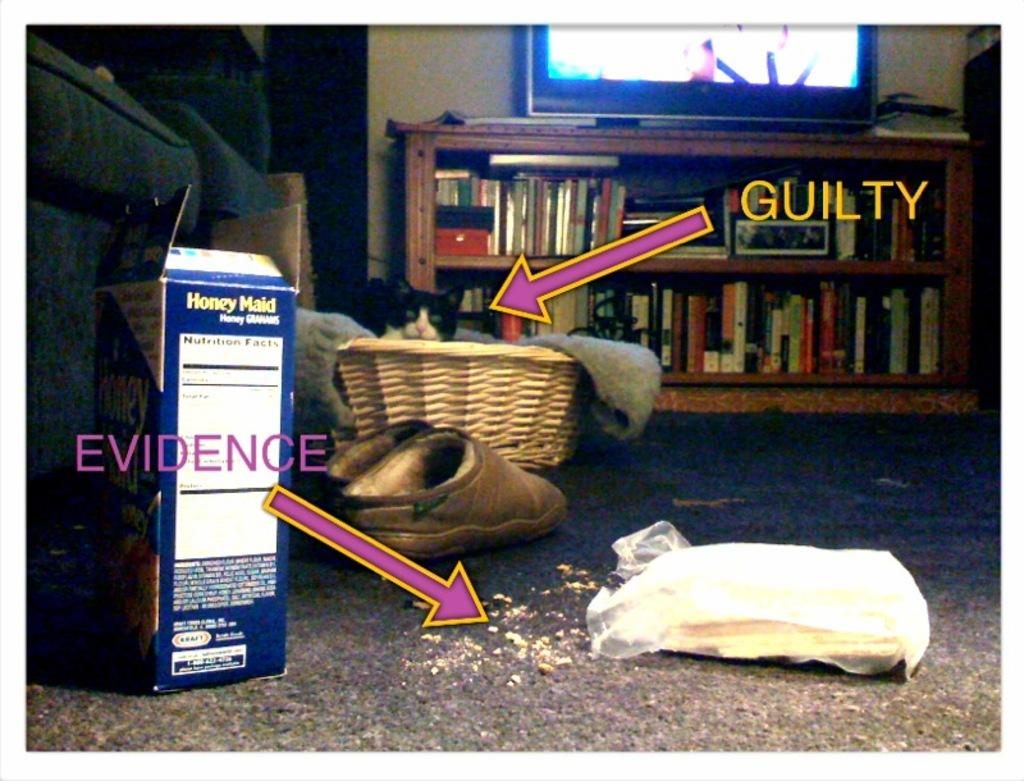Provide a one-sentence caption for the provided image. a picture with honey maid branded honey grahams with a cat in the background. 